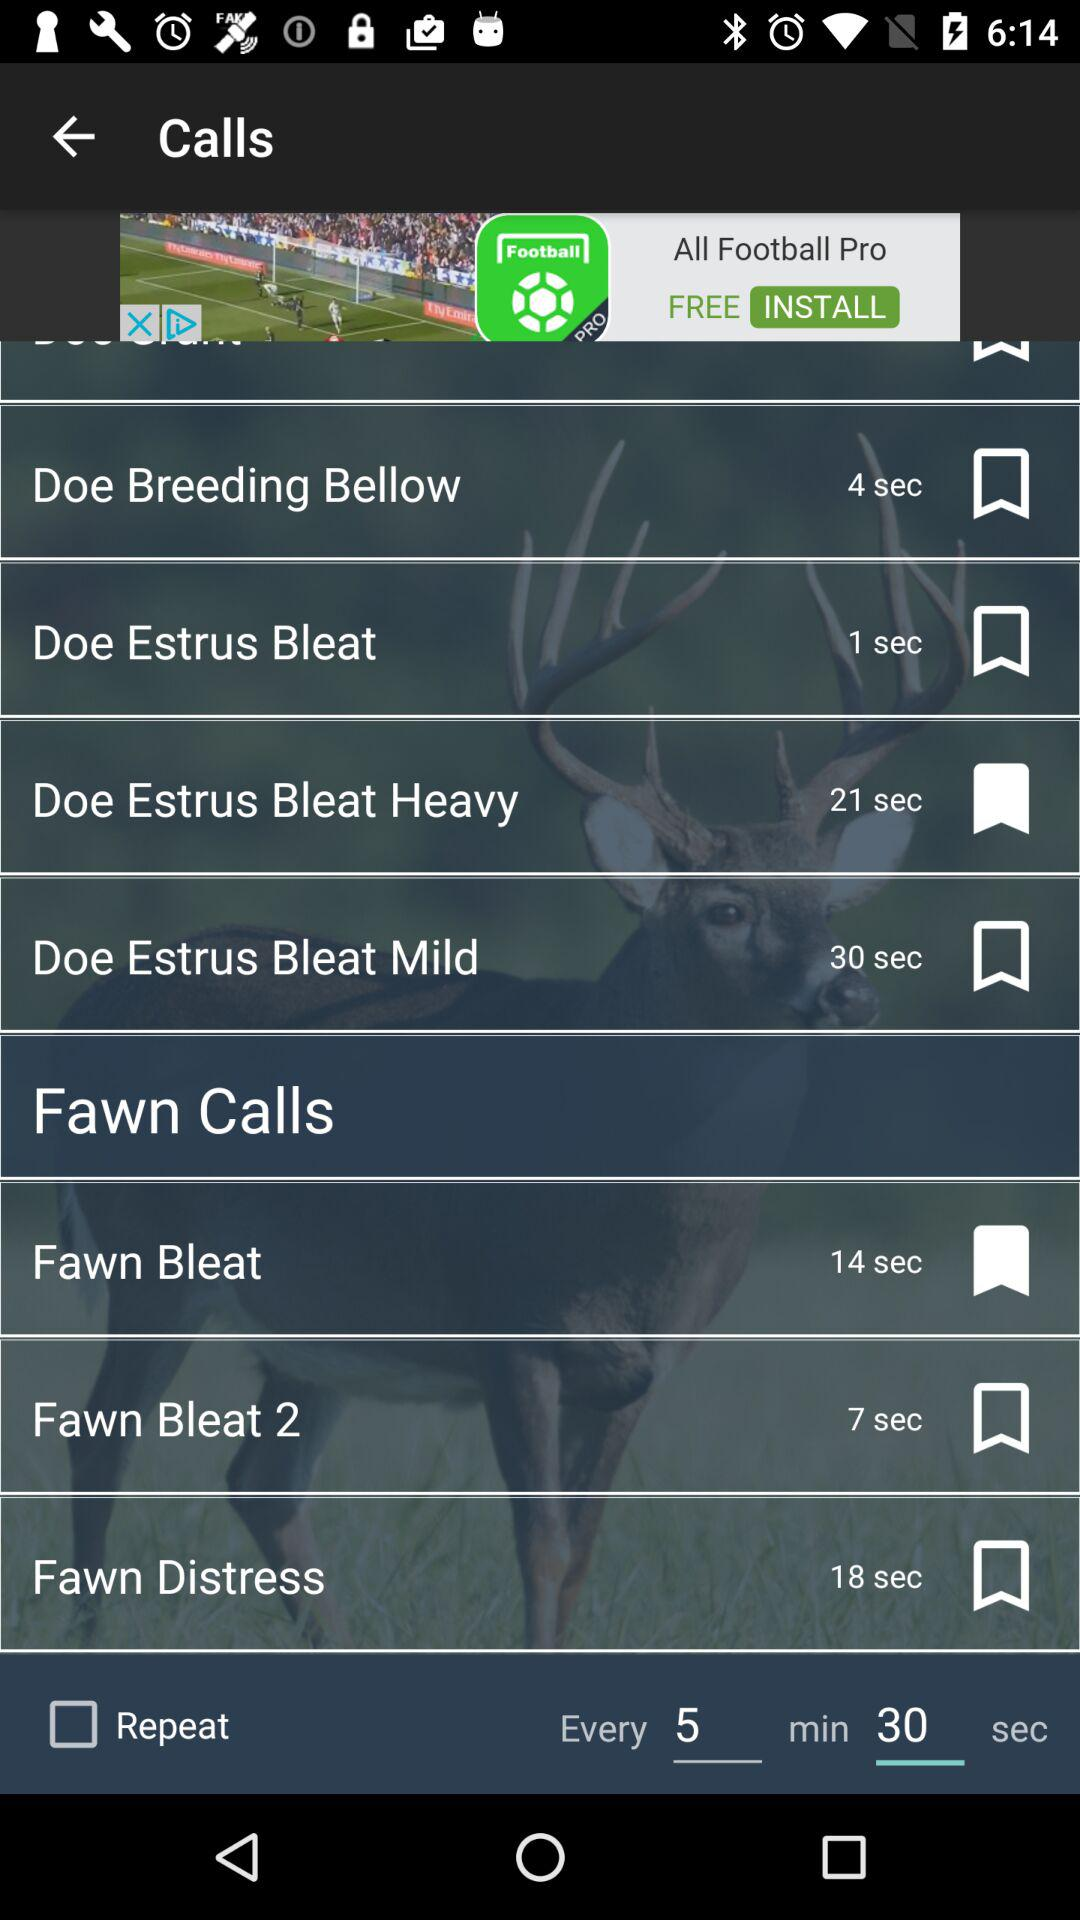Which calls are bookmarked? The bookmarked calls are "Doe Estrus Bleat Heavy" and "Fawn Bleat". 